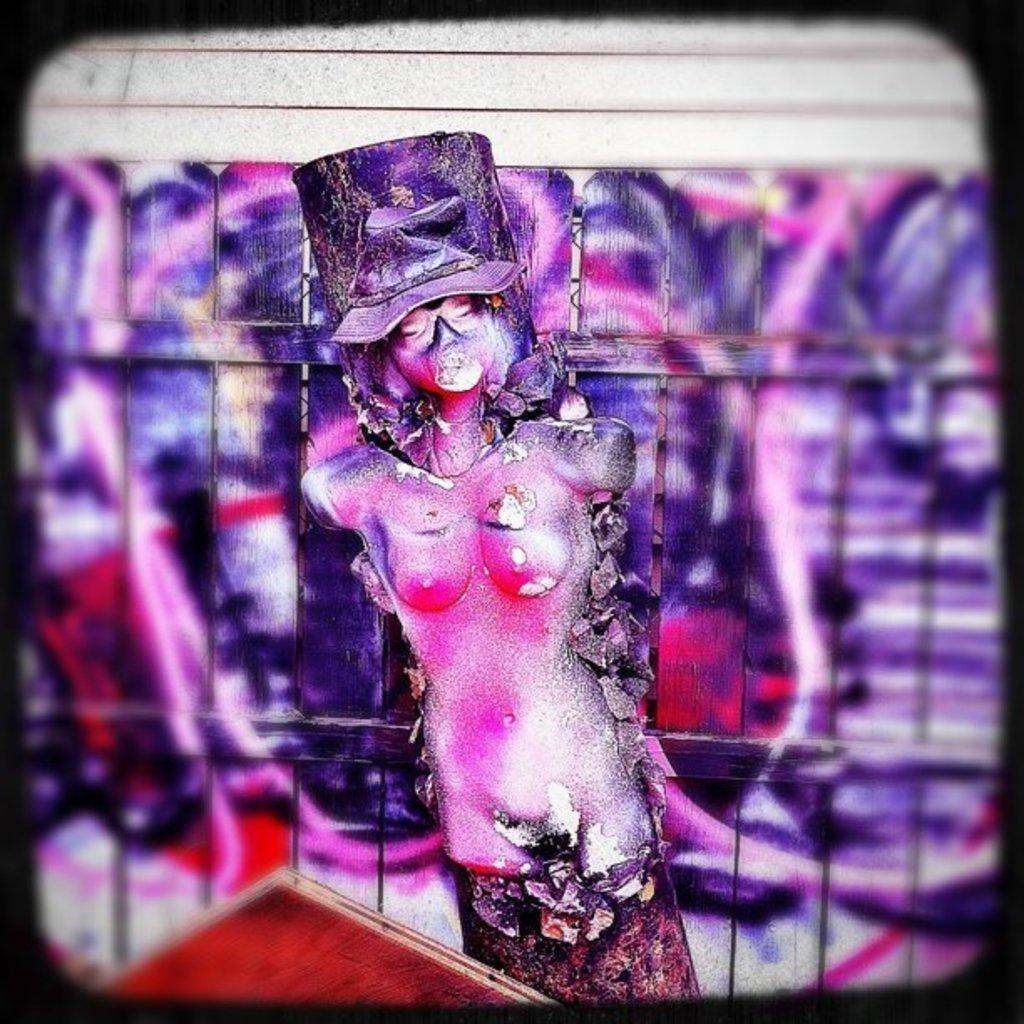What is the main subject in the foreground of the image? There is an art piece in the foreground of the image. What can be seen in the background of the image? There are wooden sticks in the background of the image. What type of plastic material is used to create the art piece in the image? There is no mention of plastic material being used in the art piece; it is not present in the image. 